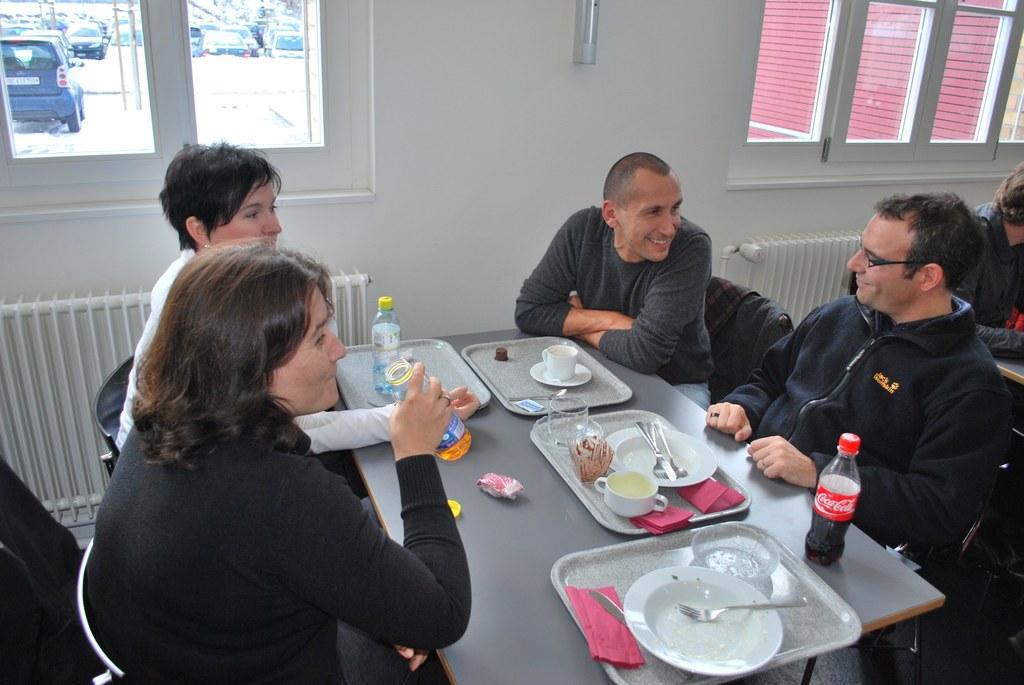Can you describe this image briefly? In this image few persons are sitting on the chairs. Before them there is a table having few trays and bottles on it. On the trays there are few cups, plates and bottle. On the plates there are forks and spoons. Right side there is a person sitting. Before him there is a table. Background there is a wall having windows. From the windows few vehicles and trees are visible. 